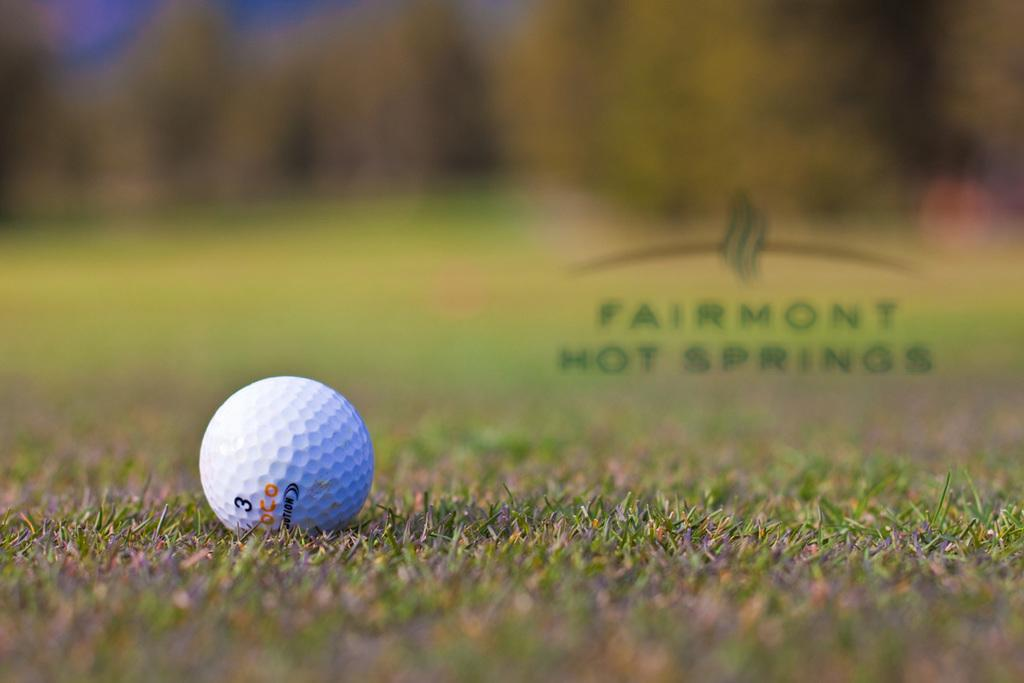What object is the main focus of the image? There is a golf ball in the image. Where is the golf ball located? The golf ball is on the grass. Can you describe the background of the image? The background of the image is blurred. What type of water can be seen flowing near the golf ball in the image? There is no water present in the image; it only features a golf ball on the grass with a blurred background. 